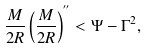Convert formula to latex. <formula><loc_0><loc_0><loc_500><loc_500>\frac { M } { 2 R } \left ( \frac { M } { 2 R } \right ) ^ { ^ { \prime \prime } } < \Psi - \Gamma ^ { 2 } ,</formula> 